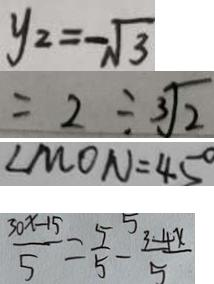<formula> <loc_0><loc_0><loc_500><loc_500>y _ { 2 } = - \sqrt { 3 } 
 = 2 \div \sqrt [ 3 ] { 2 } 
 \angle M O N = 4 5 ^ { \circ } 
 \frac { 3 0 x - 1 5 } { 5 } = \frac { 5 } { 5 } - \frac { 3 - 4 x } { 5 }</formula> 